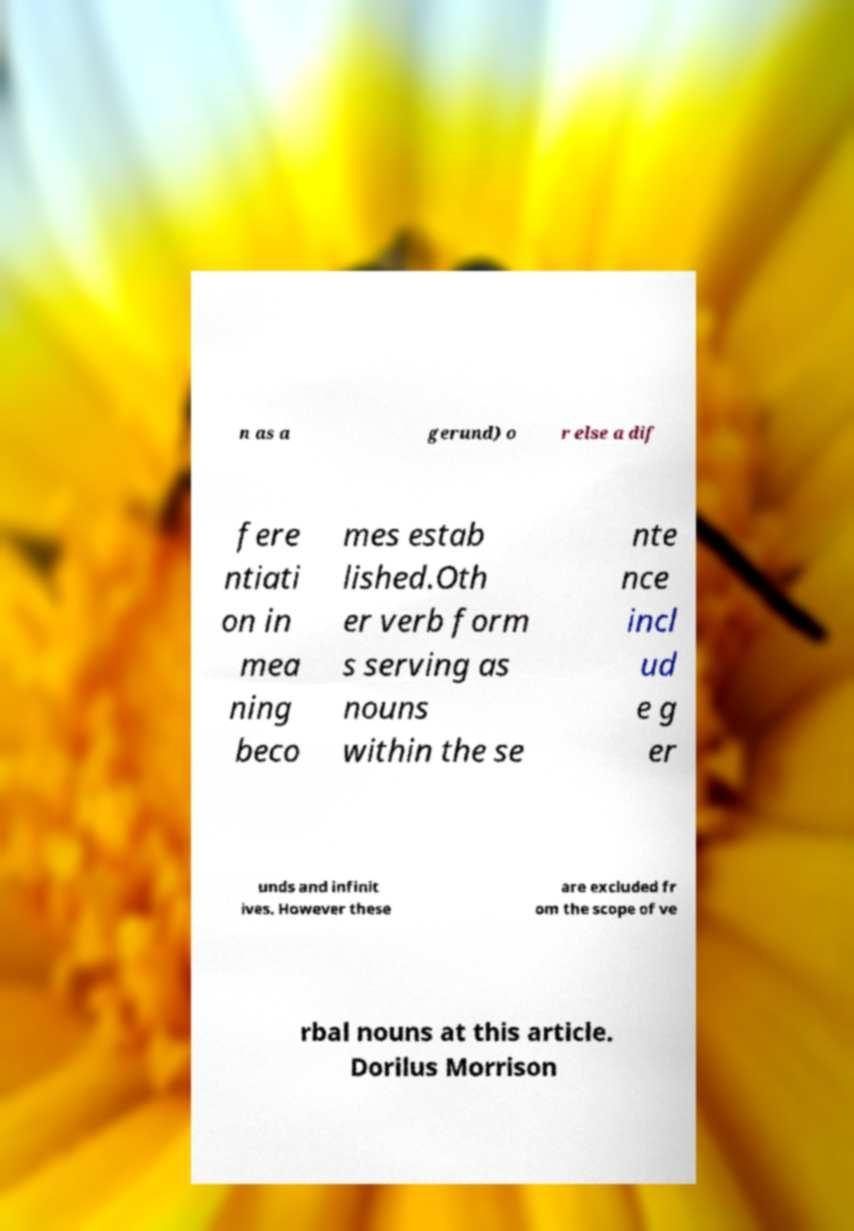There's text embedded in this image that I need extracted. Can you transcribe it verbatim? n as a gerund) o r else a dif fere ntiati on in mea ning beco mes estab lished.Oth er verb form s serving as nouns within the se nte nce incl ud e g er unds and infinit ives. However these are excluded fr om the scope of ve rbal nouns at this article. Dorilus Morrison 